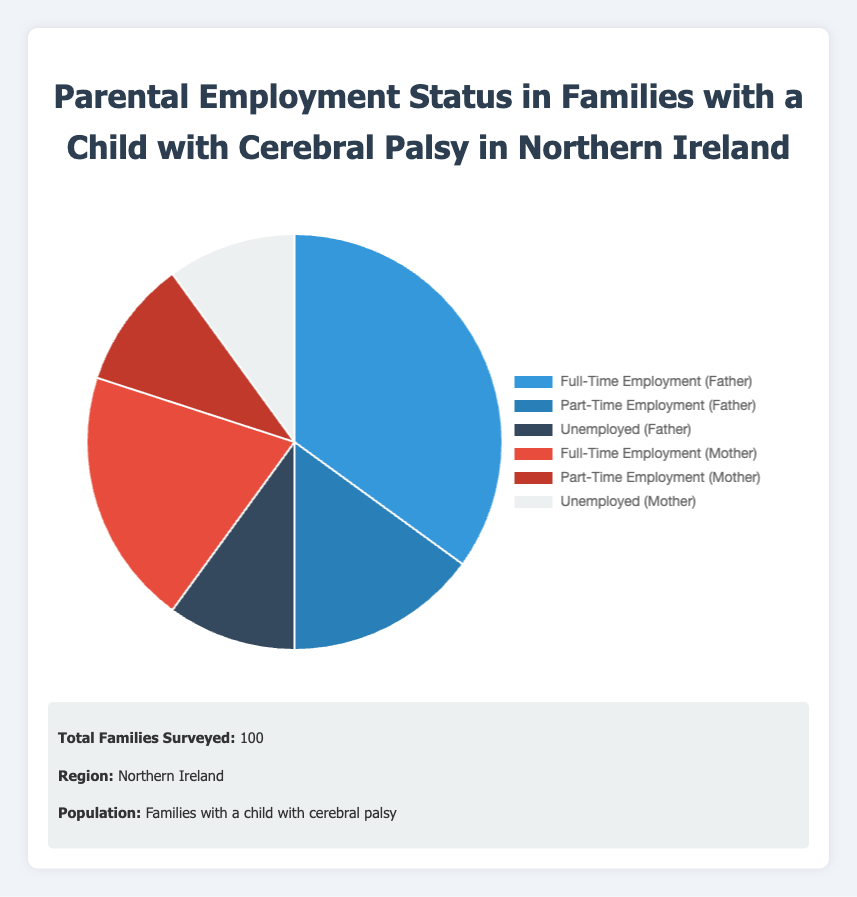What percentage of fathers are employed either full-time or part-time? To find this, we add the percentages of fathers employed full-time and part-time. From the data, full-time employment for fathers is 35%, and part-time employment for fathers is 15%. So, 35% + 15% = 50%.
Answer: 50% What is the difference in percentage between mothers in full-time employment and mothers in part-time employment? We simply subtract the percentage of mothers in part-time employment from those in full-time employment. Full-time employment for mothers is 20%, and part-time employment is 10%. So, 20% - 10% = 10%.
Answer: 10% Which parental employment status is the least common? By looking at the percentages, the least common category is the one with the smallest percentage. Both unemployed mothers and part-time employed mothers have a percentage of 10%, which is the smallest among all categories.
Answer: Unemployed (Mother) and Part-Time Employment (Mother) How does the employment rate of fathers compare to that of mothers in full-time employment? The employment rate of fathers in full-time employment is 35%, while that of mothers is 20%. We compare these two values and see that 35% (fathers) is greater than 20% (mothers).
Answer: Fathers have a higher full-time employment rate than mothers What is the combined percentage of all unemployed parents? We add the percentages of unemployed fathers and unemployed mothers. From the data, 10% of fathers and 10% of mothers are unemployed. So, 10% + 10% = 20%.
Answer: 20% What percentage of parents are employed in any capacity (full-time or part-time)? We add the percentages of parents in full-time and part-time employment for both fathers and mothers. Full-time fathers: 35%, part-time fathers: 15%, full-time mothers: 20%, part-time mothers: 10%. So, 35% + 15% + 20% + 10% = 80%.
Answer: 80% Are there more fathers or mothers unemployed according to the data? We compare the percentages of unemployed fathers (10%) and mothers (10%). Since both percentages are equal, there are the same number of mothers and fathers unemployed.
Answer: Equal What is the difference between the total percentage of employed fathers and the total percentage of employed mothers? First, we calculate the total percentage of employed fathers (full-time + part-time): 35% + 15% = 50%. Then, we calculate the total percentage of employed mothers (full-time + part-time): 20% + 10% = 30%. The difference is 50% - 30% = 20%.
Answer: 20% Which employment category occupies the largest segment in the pie chart? The largest segment in the pie chart corresponds to the category with the highest percentage. From the data, it is "Full-Time Employment (Father)" with 35%.
Answer: Full-Time Employment (Father) If the number of unemployed fathers were to double, what would the new percentage be compared to the original amount? Currently, the percentage of unemployed fathers is 10%. If this number were to double, the new percentage would be 10% * 2 = 20%.
Answer: 20% 